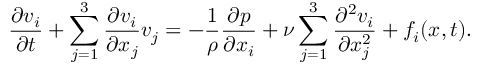Convert formula to latex. <formula><loc_0><loc_0><loc_500><loc_500>{ \frac { \partial v _ { i } } { \partial t } } + \sum _ { j = 1 } ^ { 3 } { \frac { \partial v _ { i } } { \partial x _ { j } } } v _ { j } = - { \frac { 1 } { \rho } } { \frac { \partial p } { \partial x _ { i } } } + \nu \sum _ { j = 1 } ^ { 3 } { \frac { \partial ^ { 2 } v _ { i } } { \partial x _ { j } ^ { 2 } } } + f _ { i } ( { x } , t ) .</formula> 